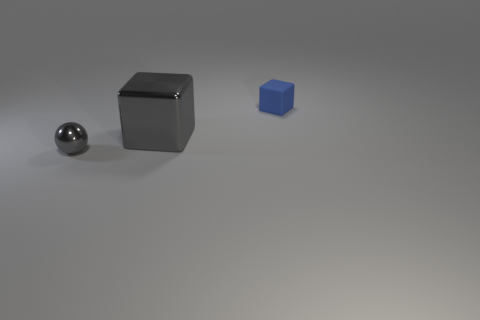Is there anything else that has the same material as the blue object?
Your answer should be very brief. No. What number of other objects are there of the same shape as the tiny metal object?
Keep it short and to the point. 0. How many blue objects are tiny blocks or big objects?
Offer a terse response. 1. What is the color of the tiny thing that is made of the same material as the big gray object?
Your answer should be compact. Gray. Is the tiny object that is in front of the blue thing made of the same material as the tiny thing behind the small ball?
Ensure brevity in your answer.  No. What size is the other thing that is the same color as the large thing?
Provide a succinct answer. Small. What is the gray thing that is to the right of the gray metal sphere made of?
Provide a succinct answer. Metal. There is a tiny thing right of the big gray block; is its shape the same as the gray thing behind the small metal ball?
Your response must be concise. Yes. Are there any large purple matte objects?
Ensure brevity in your answer.  No. There is another big object that is the same shape as the blue object; what material is it?
Offer a very short reply. Metal. 